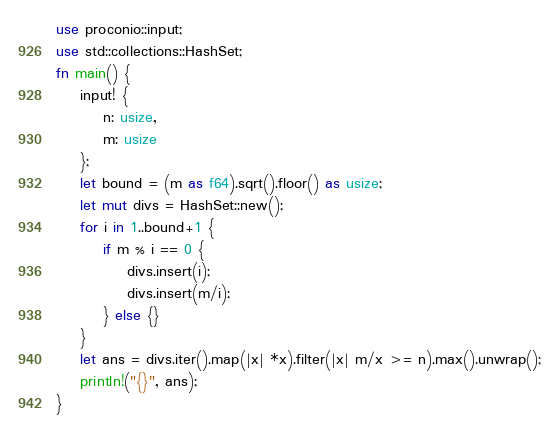Convert code to text. <code><loc_0><loc_0><loc_500><loc_500><_Rust_>use proconio::input;
use std::collections::HashSet;
fn main() {
    input! {
        n: usize,
        m: usize
    };
    let bound = (m as f64).sqrt().floor() as usize;
    let mut divs = HashSet::new();
    for i in 1..bound+1 {
        if m % i == 0 {
            divs.insert(i);
            divs.insert(m/i);
        } else {}
    }
    let ans = divs.iter().map(|x| *x).filter(|x| m/x >= n).max().unwrap();
    println!("{}", ans);
}</code> 